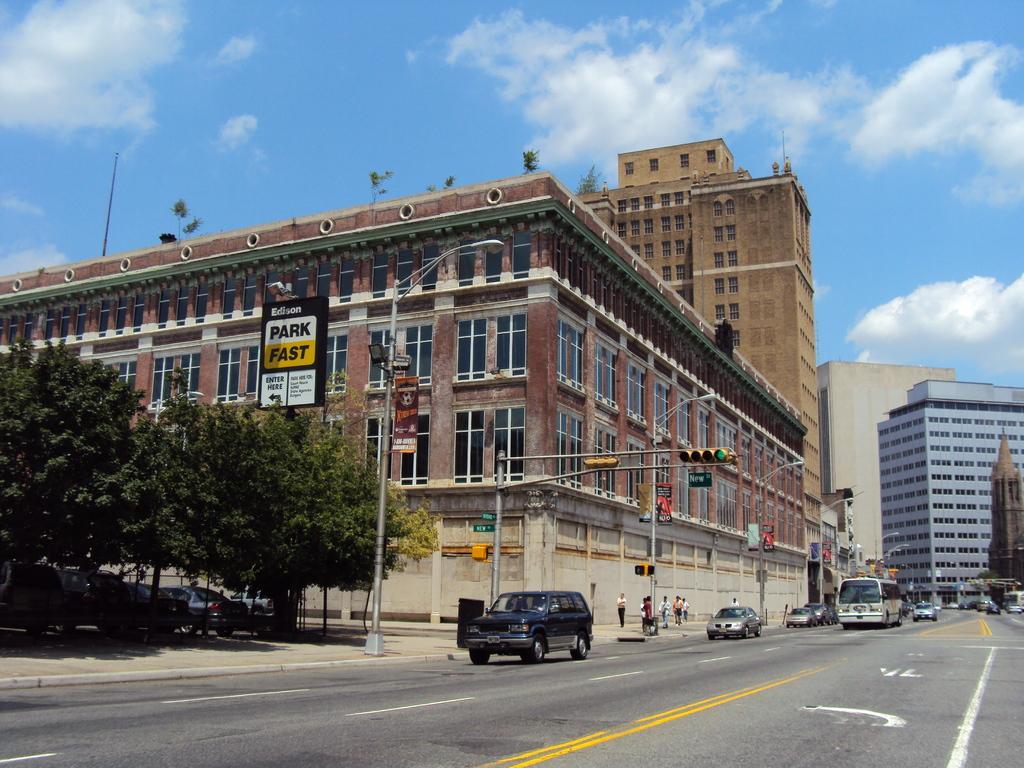Can you describe this image briefly? As we can see in the image there are buildings, trees, few people here and there, street lamps, bus and cars. On the top there is sky and clouds. 